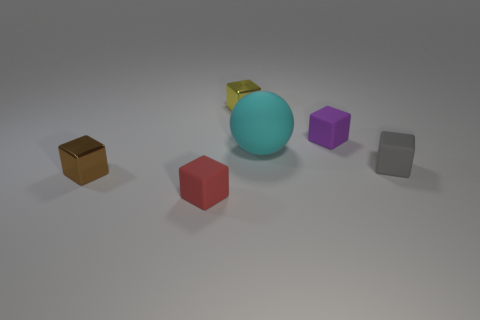Is there anything else that is the same shape as the big cyan matte thing?
Provide a short and direct response. No. There is a cyan thing that is the same material as the red cube; what is its size?
Your response must be concise. Large. The other shiny thing that is the same size as the yellow thing is what color?
Ensure brevity in your answer.  Brown. What number of other things are the same shape as the small purple object?
Keep it short and to the point. 4. There is a cyan sphere that is behind the tiny gray rubber block; what size is it?
Offer a terse response. Large. There is a tiny metal cube that is in front of the cyan rubber thing; how many objects are right of it?
Your response must be concise. 5. How many other objects are there of the same size as the red thing?
Make the answer very short. 4. Do the metal thing left of the red matte thing and the big matte object have the same shape?
Offer a very short reply. No. What number of small things are both on the right side of the big sphere and behind the purple rubber cube?
Give a very brief answer. 0. What material is the yellow object?
Give a very brief answer. Metal. 